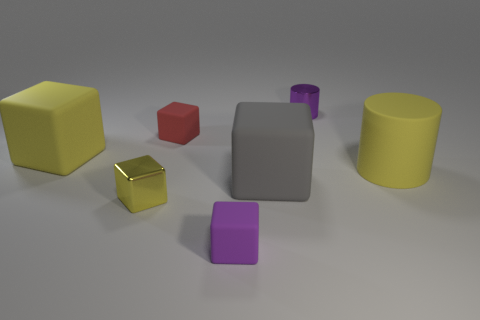Subtract all purple cubes. How many cubes are left? 4 Subtract all large yellow blocks. How many blocks are left? 4 Subtract all cyan cubes. Subtract all cyan spheres. How many cubes are left? 5 Add 2 large yellow matte objects. How many objects exist? 9 Subtract all cylinders. How many objects are left? 5 Subtract all big red matte cubes. Subtract all large rubber cubes. How many objects are left? 5 Add 5 yellow blocks. How many yellow blocks are left? 7 Add 7 tiny shiny cylinders. How many tiny shiny cylinders exist? 8 Subtract 1 gray blocks. How many objects are left? 6 